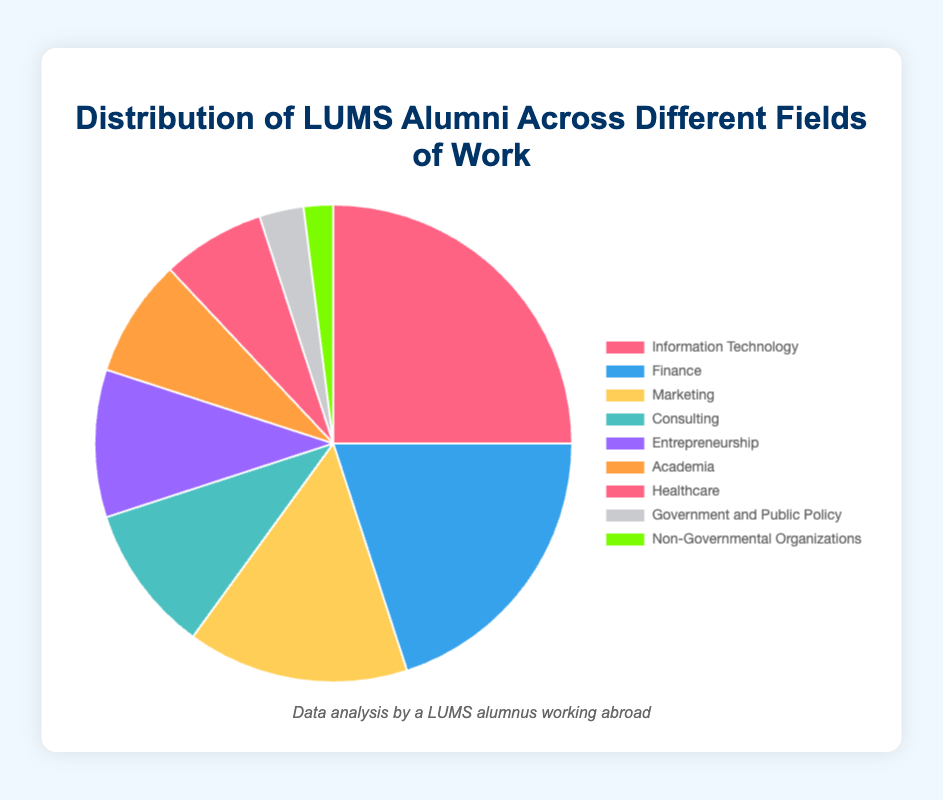Which field has the highest percentage of LUMS alumni? The figure shows the distribution of percentages for various fields. Information Technology has the largest slice, indicating it has the highest percentage.
Answer: Information Technology Which two fields combined have the same percentage as Information Technology? We look for two fields whose percentages sum to 25% (the percentage for Information Technology). Finance (20%) and Government and Public Policy (3%) together with Non-Governmental Organizations (2%) sum up to 25%.
Answer: Finance and Government and Public Policy, along with Non-Governmental Organizations What is the difference in percentage between the fields of Marketing and Academia? Marketing has a percentage of 15%, and Academia has a percentage of 8%. Subtracting these gives us 15% - 8% = 7%.
Answer: 7% How many fields have a percentage of 10% or higher? The figure shows the percentage values for each field. Information Technology, Finance, Marketing, Consulting, and Entrepreneurship all have percentages of 10% or higher. Counting these fields, we get 5.
Answer: 5 Which field has a percentage closest to Healthcare? Healthcare has a percentage of 7%. Academia has a percentage of 8% which is the closest to 7%.
Answer: Academia What is the total percentage of alumni working in Consulting, Entrepreneurship, and Government and Public Policy? We sum the percentages for Consulting (10%), Entrepreneurship (10%), and Government and Public Policy (3%). This gives us 10% + 10% + 3% = 23%.
Answer: 23% What percentage of alumni work in fields represented by the bottom three percentages? The bottom three fields by percentage are Government and Public Policy (3%), Non-Governmental Organizations (2%), and Healthcare (7%). Summing these gives 3% + 2% + 7% = 12%.
Answer: 12% Which field has a color that stands out visually because of its distinctiveness? The pie chart uses a variety of colors. The field with the most visually distinctive and bright color likely stands out the most, which appears to be Non-Governmental Organizations with its bright green color.
Answer: Non-Governmental Organizations How does the percentage of alumni in Finance compare to the percentage in Marketing? Finance has a percentage of 20%, while Marketing has 15%. Finance has a higher percentage by 5%.
Answer: Finance is higher by 5% 